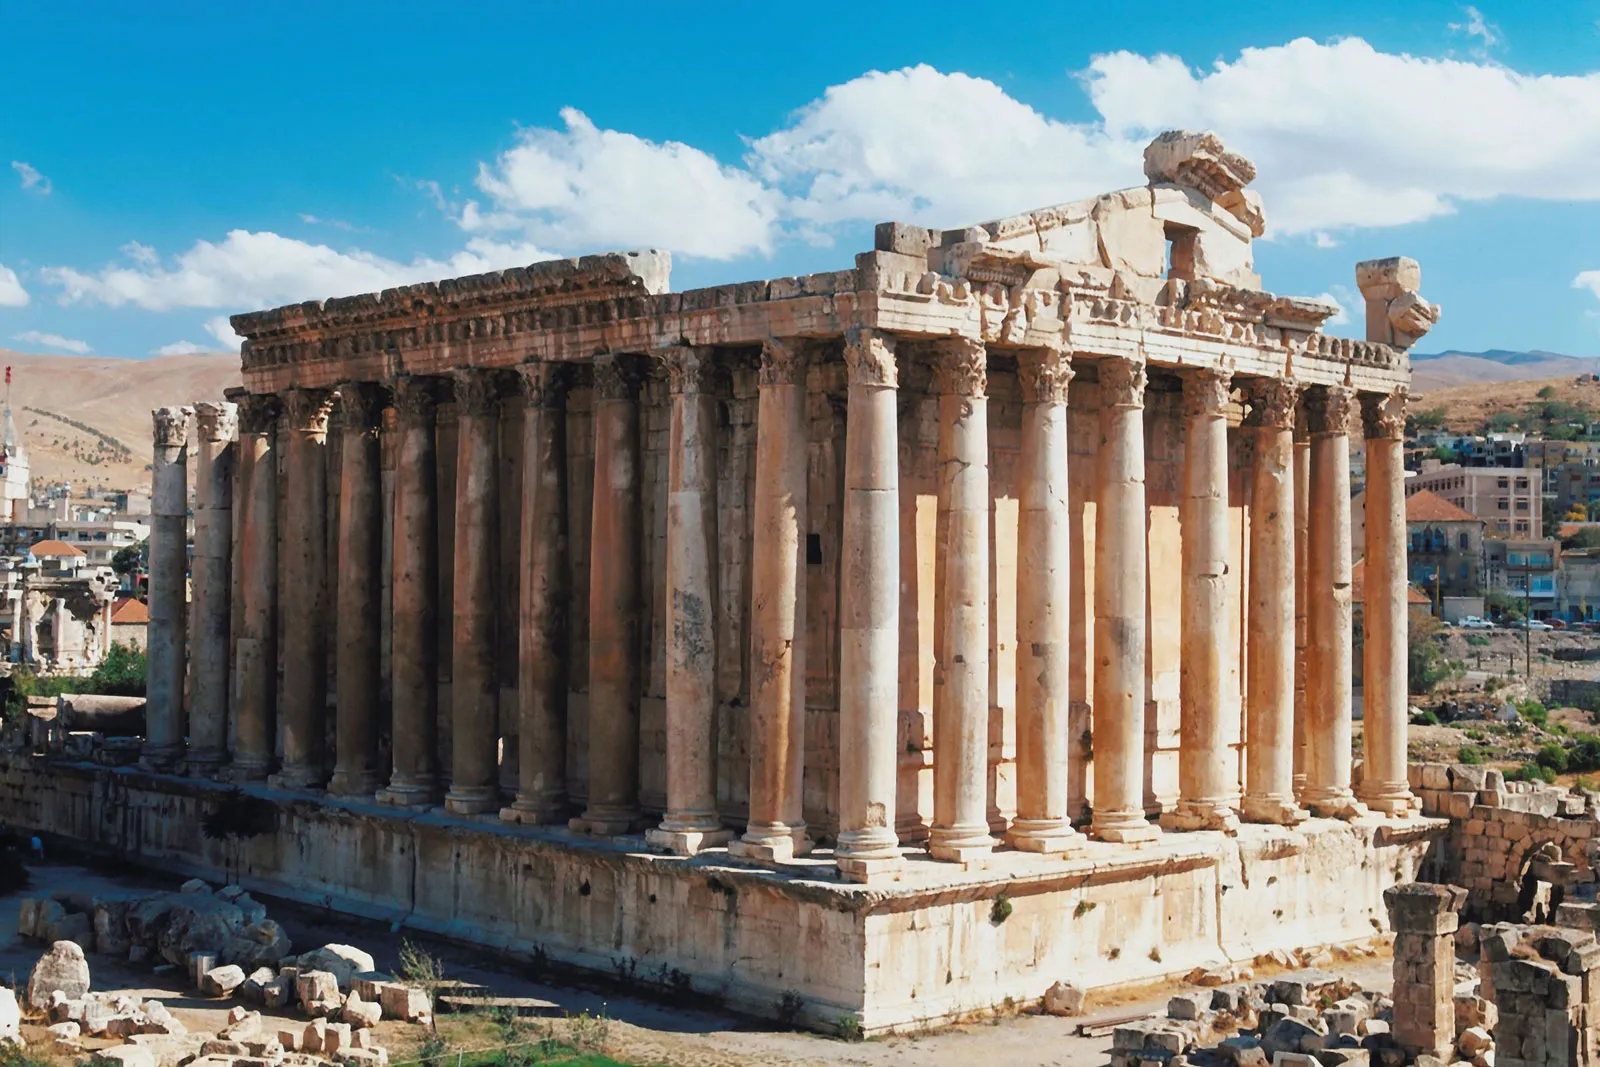What do you see happening in this image? The image showcases the impressive Temple of Jupiter at Baalbek in Lebanon, renowned for its monumental scale and the sophisticated classical style of its architecture. Erected during antiquity, the temple stands out with its formidable row of towering columns, each meticulously crafted from local stone that has weathered over millennia, adding a narrative of resilience and historical endurance. The temple's orientation provides a majestic panoramic view, framed by Lebanon's rugged mountains, offering a profound connection between human achievement and the sublime natural landscape that surrounds it. 